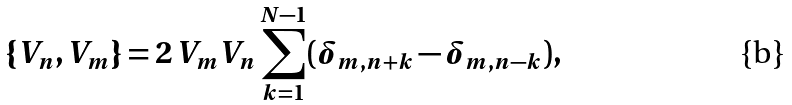Convert formula to latex. <formula><loc_0><loc_0><loc_500><loc_500>\{ V _ { n } , V _ { m } \} = 2 \, V _ { m } V _ { n } \sum _ { k = 1 } ^ { N - 1 } ( \delta _ { m , n + k } - \delta _ { m , n - k } ) ,</formula> 